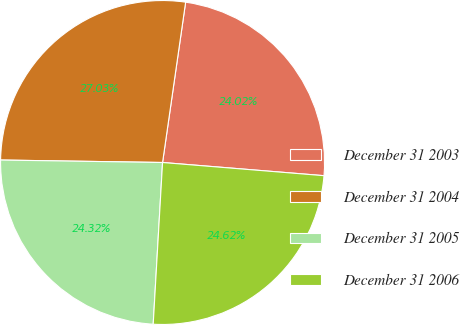Convert chart. <chart><loc_0><loc_0><loc_500><loc_500><pie_chart><fcel>December 31 2003<fcel>December 31 2004<fcel>December 31 2005<fcel>December 31 2006<nl><fcel>24.02%<fcel>27.03%<fcel>24.32%<fcel>24.62%<nl></chart> 